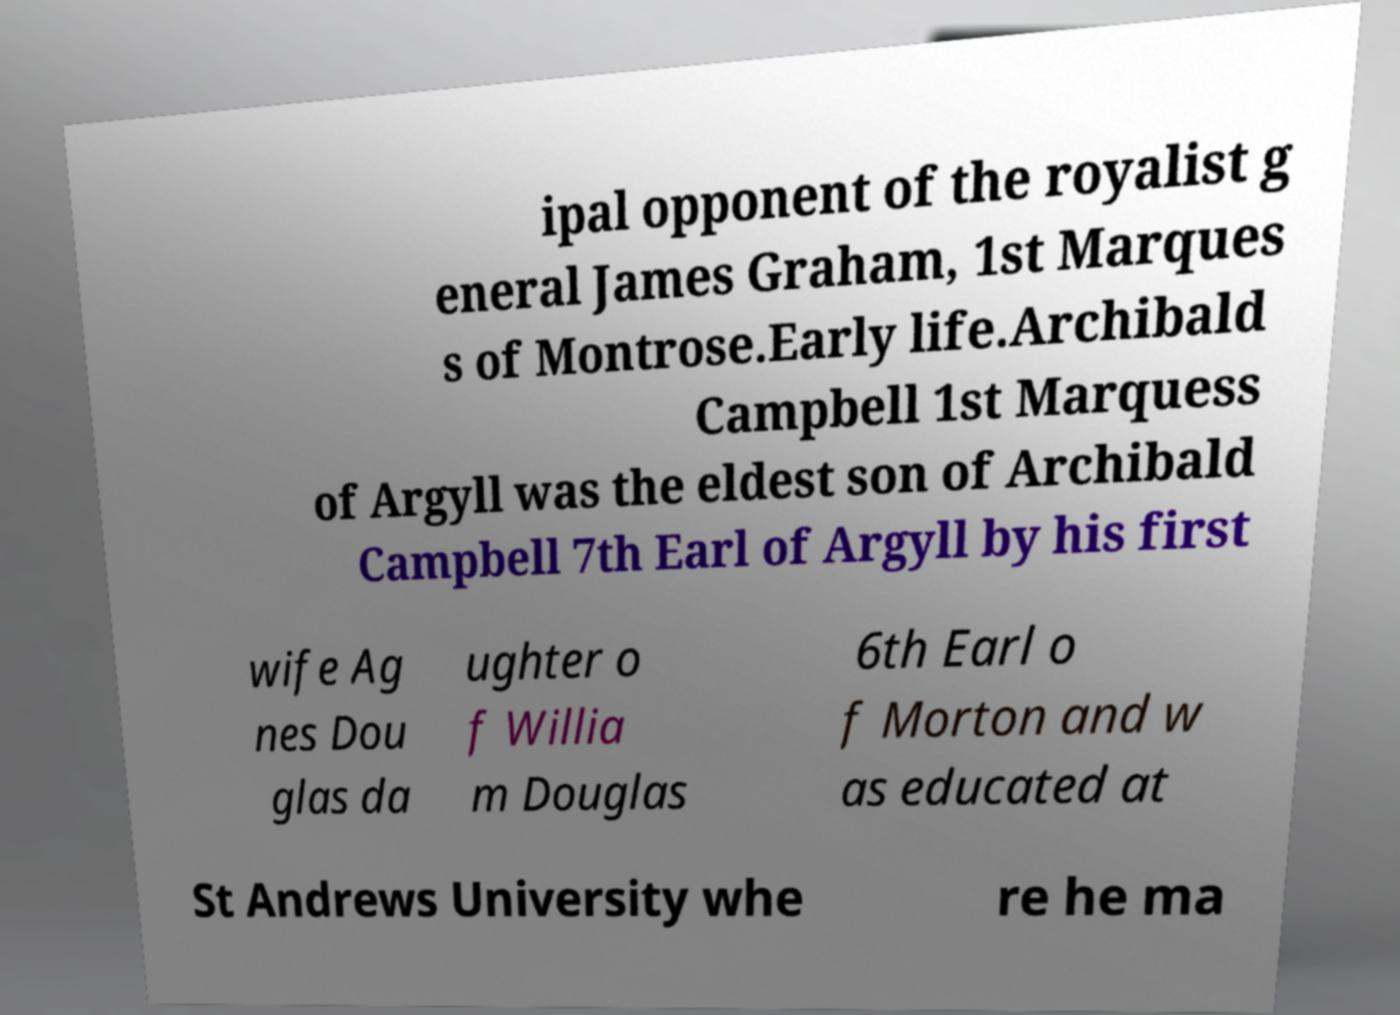Could you extract and type out the text from this image? ipal opponent of the royalist g eneral James Graham, 1st Marques s of Montrose.Early life.Archibald Campbell 1st Marquess of Argyll was the eldest son of Archibald Campbell 7th Earl of Argyll by his first wife Ag nes Dou glas da ughter o f Willia m Douglas 6th Earl o f Morton and w as educated at St Andrews University whe re he ma 